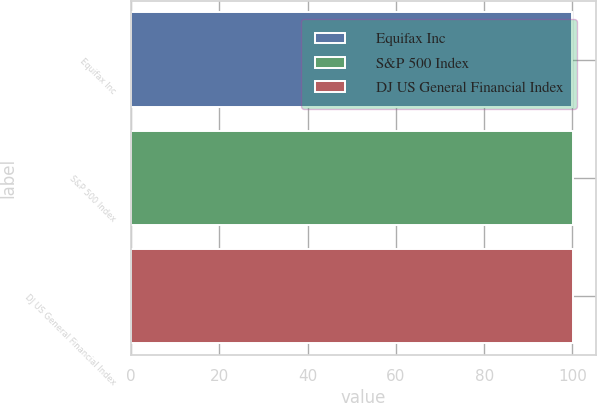<chart> <loc_0><loc_0><loc_500><loc_500><bar_chart><fcel>Equifax Inc<fcel>S&P 500 Index<fcel>DJ US General Financial Index<nl><fcel>100<fcel>100.1<fcel>100.2<nl></chart> 